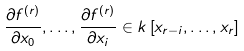<formula> <loc_0><loc_0><loc_500><loc_500>\frac { \partial f ^ { ( r ) } } { \partial x _ { 0 } } , \dots , \frac { \partial f ^ { ( r ) } } { \partial x _ { i } } \in k \left [ x _ { r - i } , \dots , x _ { r } \right ]</formula> 